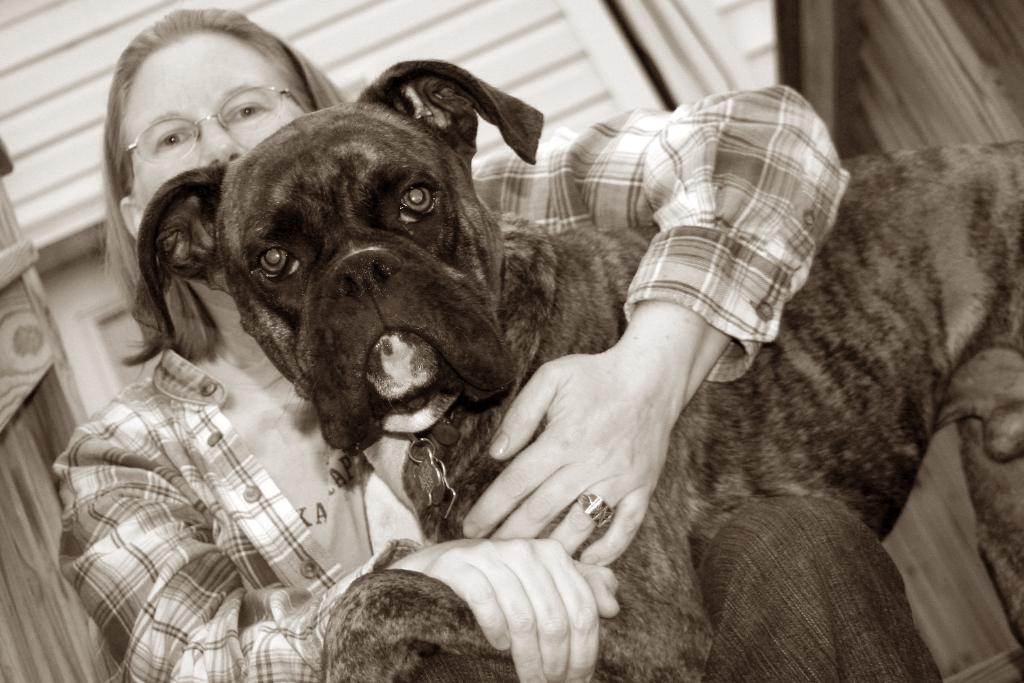What is the main subject in the center of the image? There is a dog in the center of the image. Who else is present in the image? There is a lady in the image. What can be observed about the lady's appearance? The lady is wearing glasses. How is the dog being held in the image? The lady is holding the dog in her hands. What type of pen is the dog using to write in the image? There is no pen present in the image, and the dog is not shown writing. 